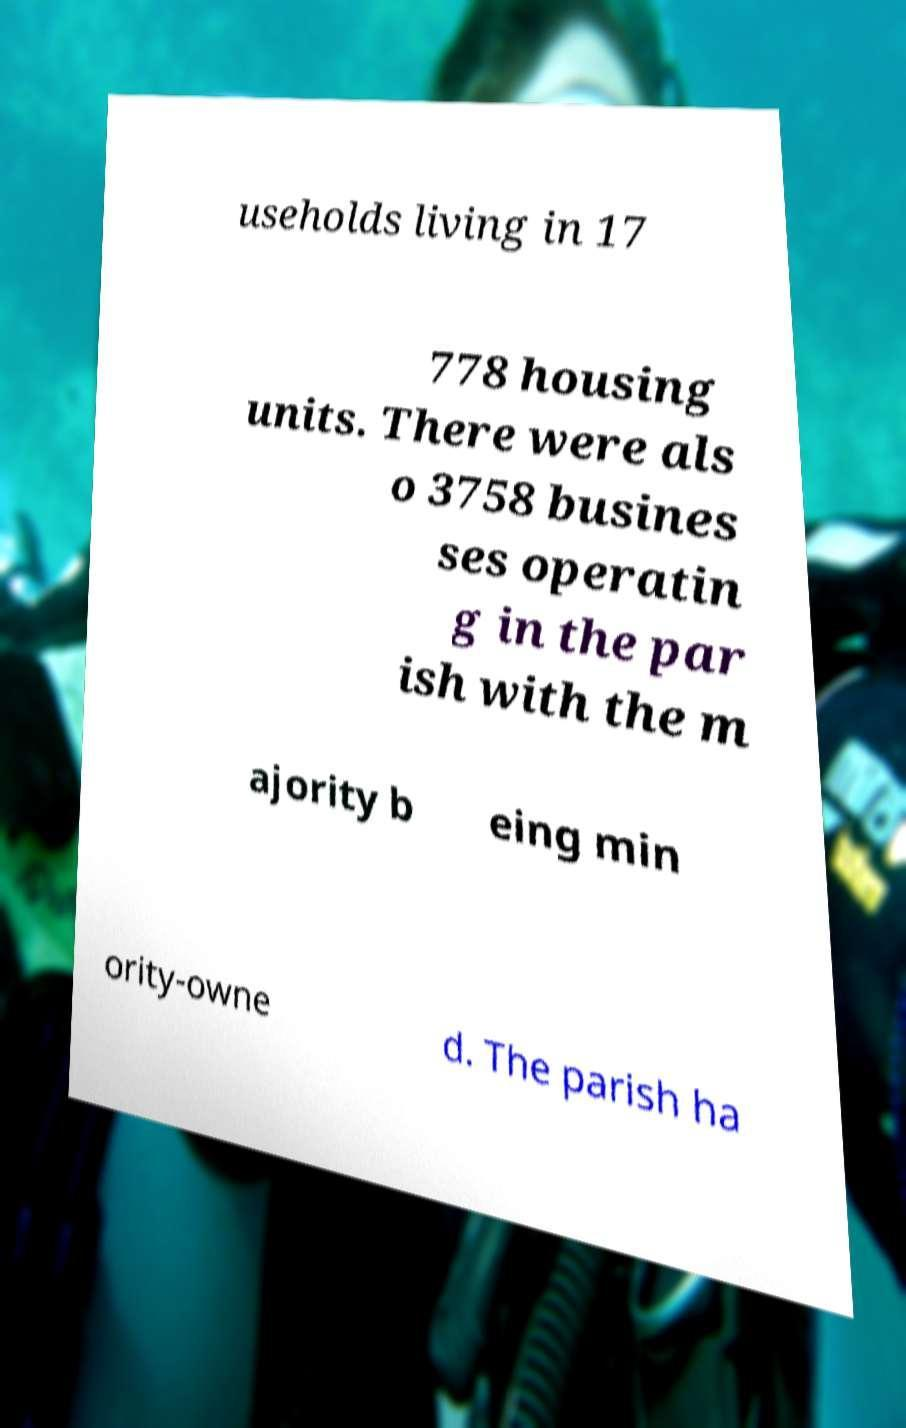Please identify and transcribe the text found in this image. useholds living in 17 778 housing units. There were als o 3758 busines ses operatin g in the par ish with the m ajority b eing min ority-owne d. The parish ha 